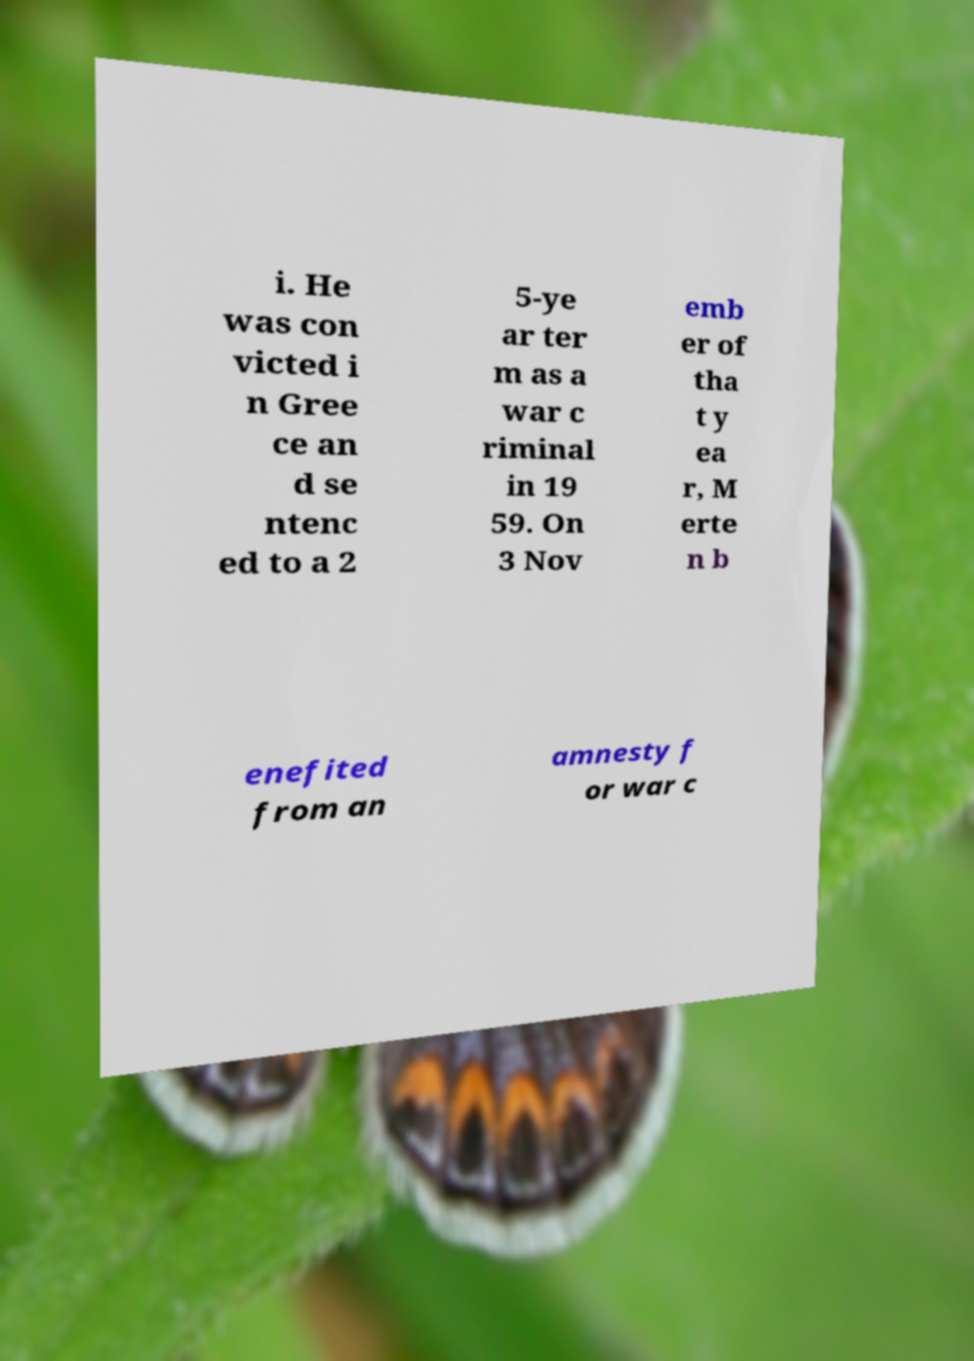Could you assist in decoding the text presented in this image and type it out clearly? i. He was con victed i n Gree ce an d se ntenc ed to a 2 5-ye ar ter m as a war c riminal in 19 59. On 3 Nov emb er of tha t y ea r, M erte n b enefited from an amnesty f or war c 